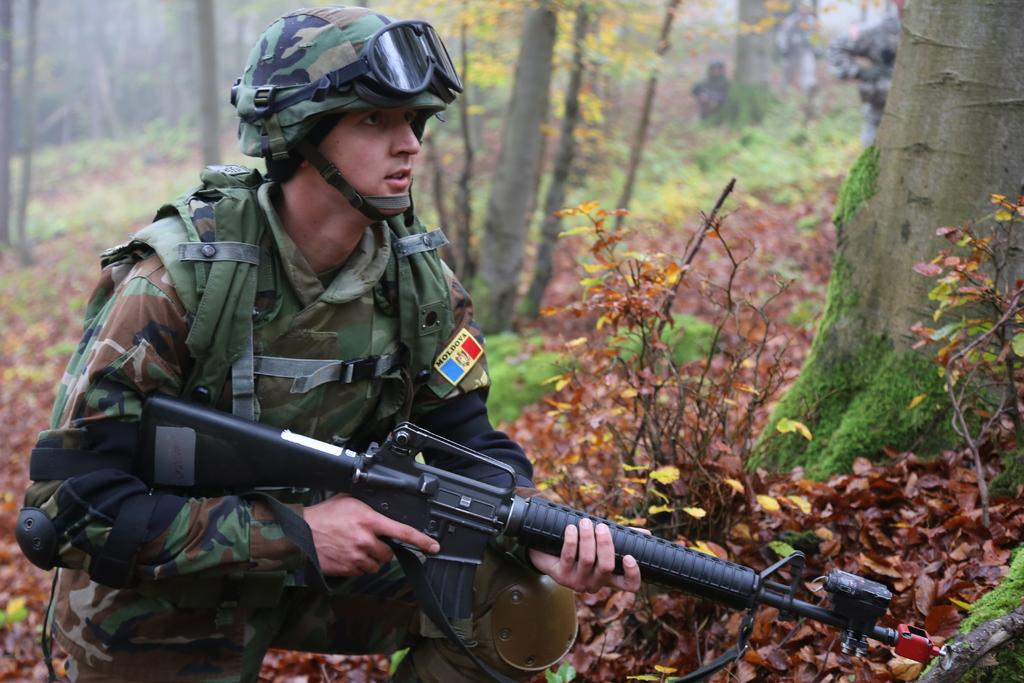What can be seen in the image related to a person? There is a person in the image, and they are wearing a helmet and holding a gun. What protective gear is the person wearing? The person is wearing a helmet with a goggle. What is on the ground in the image? There are leaves on the ground. What type of environment is depicted in the image? There are many trees in the image, suggesting a forest or wooded area. What type of ink can be seen on the leaves in the image? There is no ink visible on the leaves in the image. The leaves appear to be natural and not altered in any way. 